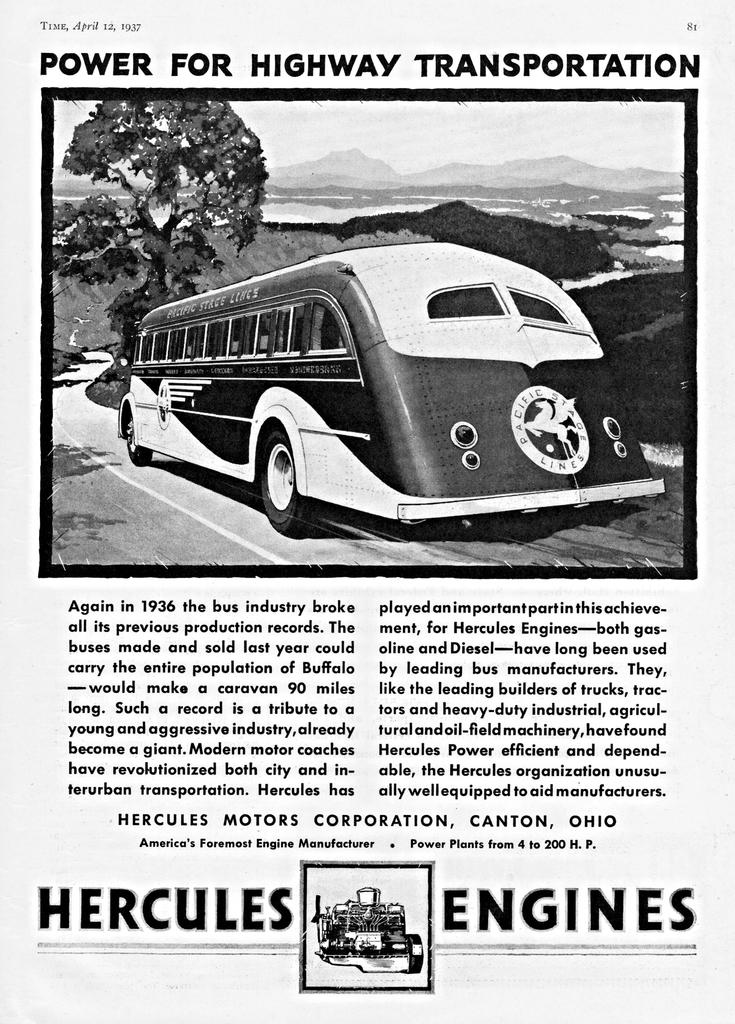What is the main subject of the paper in the image? The paper has a picture of a bus. What other elements are included in the picture on the paper? The picture on the paper includes a tree, mountains, and the sky. Is there any text on the paper? Yes, there is text on the paper. Can you see a tramp playing with a jar on the seashore in the image? No, there is no tramp, jar, or seashore present in the image. The image only features a paper with a picture of a bus and related elements, along with some text. 